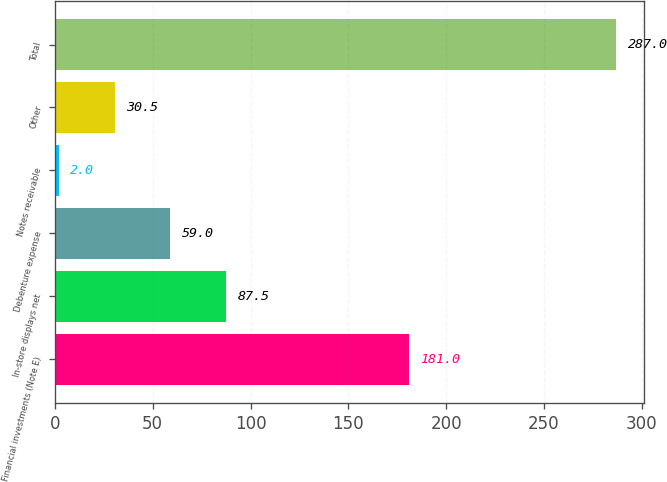Convert chart. <chart><loc_0><loc_0><loc_500><loc_500><bar_chart><fcel>Financial investments (Note E)<fcel>In-store displays net<fcel>Debenture expense<fcel>Notes receivable<fcel>Other<fcel>Total<nl><fcel>181<fcel>87.5<fcel>59<fcel>2<fcel>30.5<fcel>287<nl></chart> 